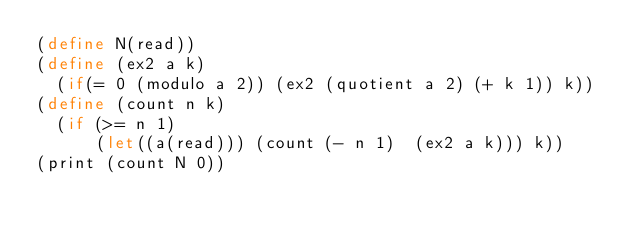<code> <loc_0><loc_0><loc_500><loc_500><_Scheme_>(define N(read))
(define (ex2 a k)
  (if(= 0 (modulo a 2)) (ex2 (quotient a 2) (+ k 1)) k))
(define (count n k)
  (if (>= n 1)
      (let((a(read))) (count (- n 1)  (ex2 a k))) k))
(print (count N 0))</code> 